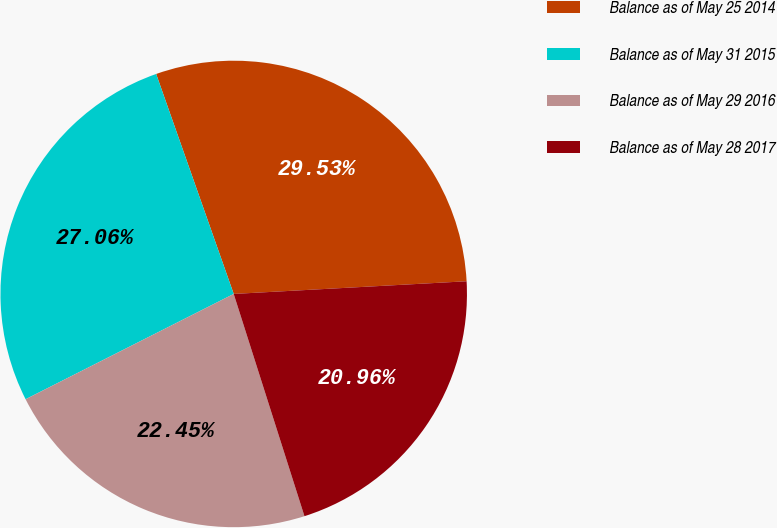Convert chart. <chart><loc_0><loc_0><loc_500><loc_500><pie_chart><fcel>Balance as of May 25 2014<fcel>Balance as of May 31 2015<fcel>Balance as of May 29 2016<fcel>Balance as of May 28 2017<nl><fcel>29.53%<fcel>27.06%<fcel>22.45%<fcel>20.96%<nl></chart> 